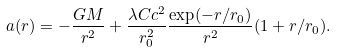<formula> <loc_0><loc_0><loc_500><loc_500>a ( r ) = - \frac { G M } { r ^ { 2 } } + \frac { \lambda C c ^ { 2 } } { r _ { 0 } ^ { 2 } } \frac { \exp ( - r / r _ { 0 } ) } { r ^ { 2 } } ( 1 + r / r _ { 0 } ) .</formula> 